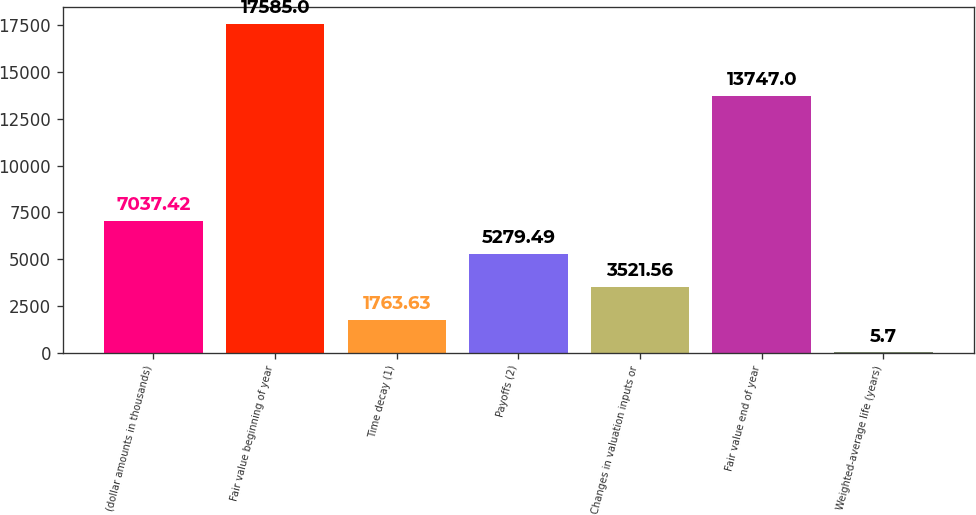<chart> <loc_0><loc_0><loc_500><loc_500><bar_chart><fcel>(dollar amounts in thousands)<fcel>Fair value beginning of year<fcel>Time decay (1)<fcel>Payoffs (2)<fcel>Changes in valuation inputs or<fcel>Fair value end of year<fcel>Weighted-average life (years)<nl><fcel>7037.42<fcel>17585<fcel>1763.63<fcel>5279.49<fcel>3521.56<fcel>13747<fcel>5.7<nl></chart> 